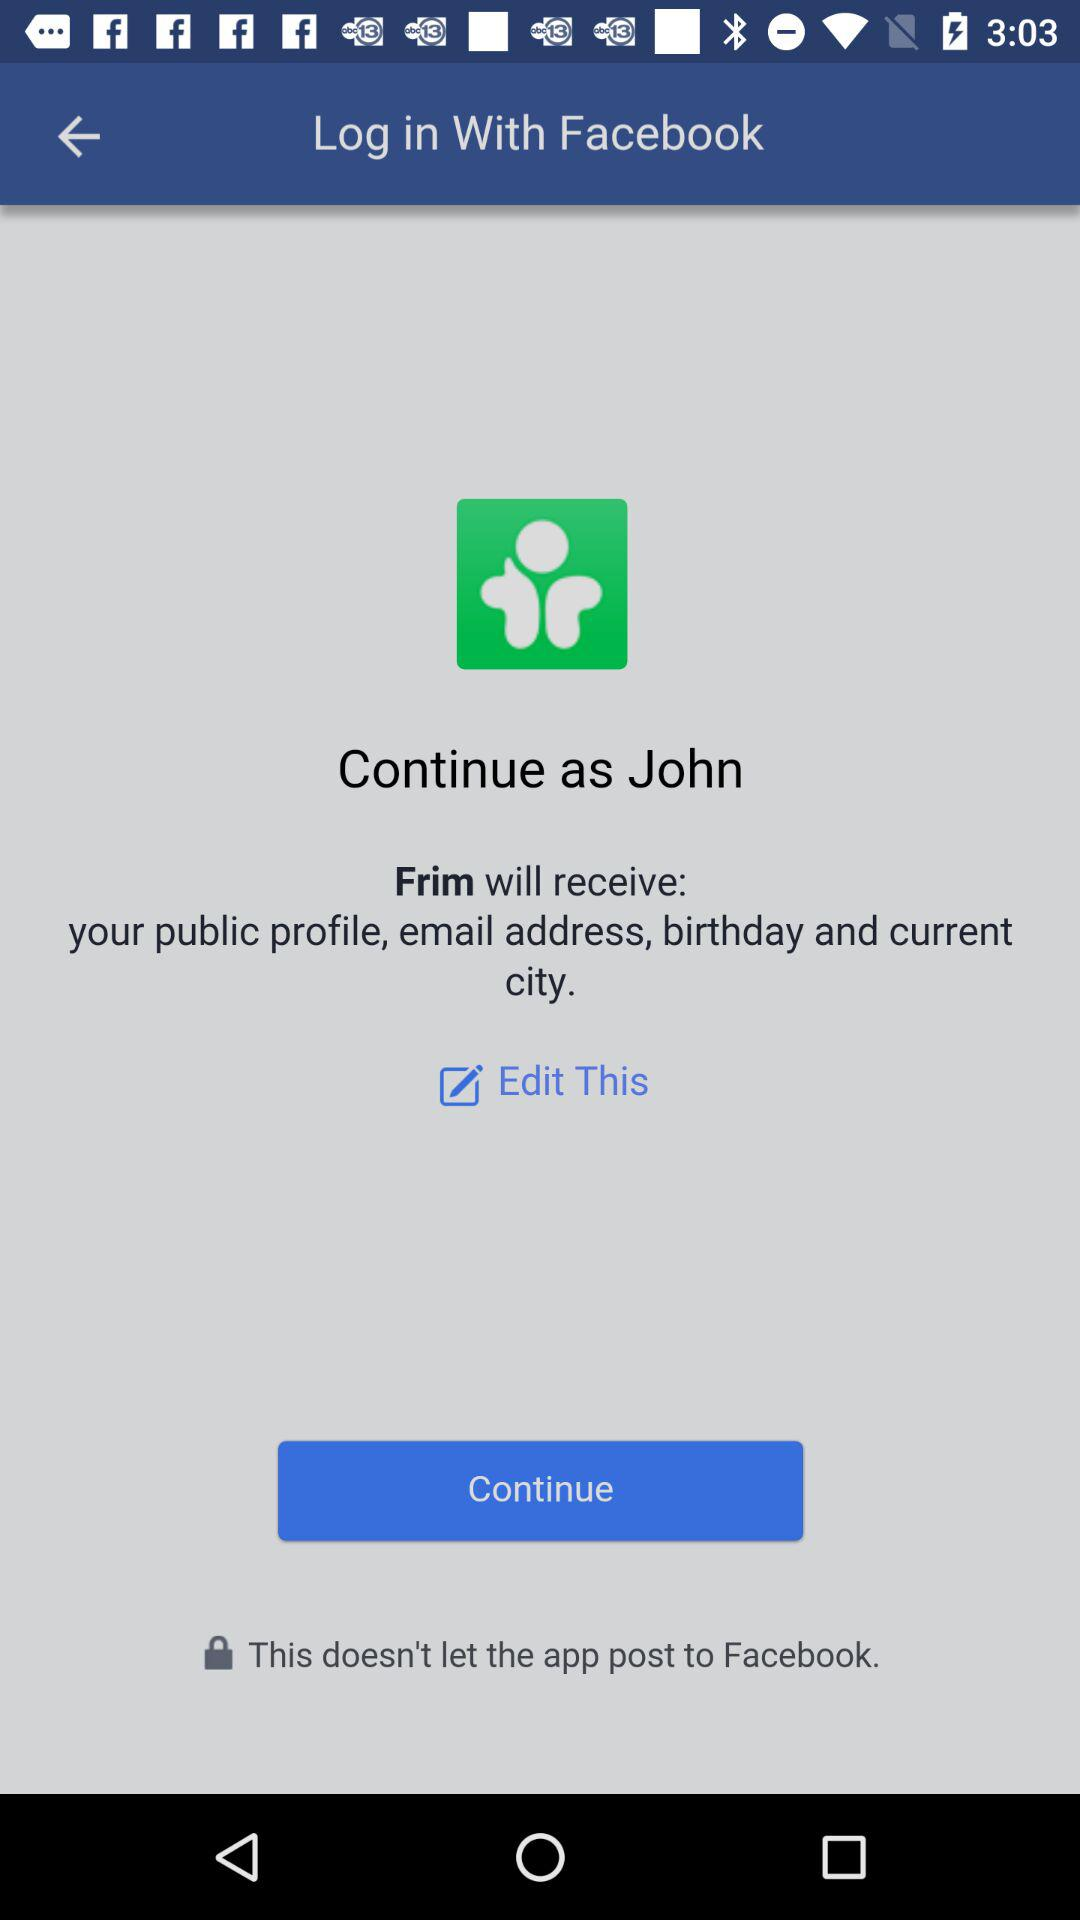What is the name of the user? The name of the user is John. 